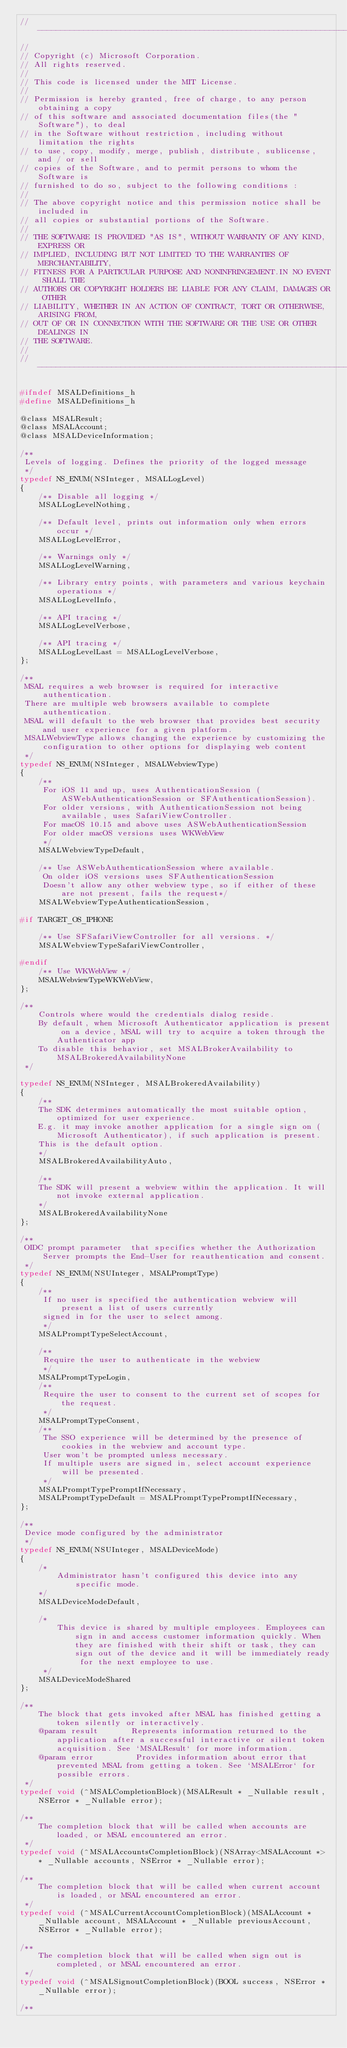Convert code to text. <code><loc_0><loc_0><loc_500><loc_500><_C_>//------------------------------------------------------------------------------
//
// Copyright (c) Microsoft Corporation.
// All rights reserved.
//
// This code is licensed under the MIT License.
//
// Permission is hereby granted, free of charge, to any person obtaining a copy
// of this software and associated documentation files(the "Software"), to deal
// in the Software without restriction, including without limitation the rights
// to use, copy, modify, merge, publish, distribute, sublicense, and / or sell
// copies of the Software, and to permit persons to whom the Software is
// furnished to do so, subject to the following conditions :
//
// The above copyright notice and this permission notice shall be included in
// all copies or substantial portions of the Software.
//
// THE SOFTWARE IS PROVIDED "AS IS", WITHOUT WARRANTY OF ANY KIND, EXPRESS OR
// IMPLIED, INCLUDING BUT NOT LIMITED TO THE WARRANTIES OF MERCHANTABILITY,
// FITNESS FOR A PARTICULAR PURPOSE AND NONINFRINGEMENT.IN NO EVENT SHALL THE
// AUTHORS OR COPYRIGHT HOLDERS BE LIABLE FOR ANY CLAIM, DAMAGES OR OTHER
// LIABILITY, WHETHER IN AN ACTION OF CONTRACT, TORT OR OTHERWISE, ARISING FROM,
// OUT OF OR IN CONNECTION WITH THE SOFTWARE OR THE USE OR OTHER DEALINGS IN
// THE SOFTWARE.
//
//------------------------------------------------------------------------------

#ifndef MSALDefinitions_h
#define MSALDefinitions_h

@class MSALResult;
@class MSALAccount;
@class MSALDeviceInformation;

/**
 Levels of logging. Defines the priority of the logged message
 */
typedef NS_ENUM(NSInteger, MSALLogLevel)
{
    /** Disable all logging */
    MSALLogLevelNothing,
    
    /** Default level, prints out information only when errors occur */
    MSALLogLevelError,
    
    /** Warnings only */
    MSALLogLevelWarning,
    
    /** Library entry points, with parameters and various keychain operations */
    MSALLogLevelInfo,
    
    /** API tracing */
    MSALLogLevelVerbose,
    
    /** API tracing */
    MSALLogLevelLast = MSALLogLevelVerbose,
};

/**
 MSAL requires a web browser is required for interactive authentication.
 There are multiple web browsers available to complete authentication.
 MSAL will default to the web browser that provides best security and user experience for a given platform.
 MSALWebviewType allows changing the experience by customizing the configuration to other options for displaying web content
 */
typedef NS_ENUM(NSInteger, MSALWebviewType)
{
    /**
     For iOS 11 and up, uses AuthenticationSession (ASWebAuthenticationSession or SFAuthenticationSession).
     For older versions, with AuthenticationSession not being available, uses SafariViewController.
     For macOS 10.15 and above uses ASWebAuthenticationSession
     For older macOS versions uses WKWebView
     */
    MSALWebviewTypeDefault,
    
    /** Use ASWebAuthenticationSession where available.
     On older iOS versions uses SFAuthenticationSession
     Doesn't allow any other webview type, so if either of these are not present, fails the request*/
    MSALWebviewTypeAuthenticationSession,
    
#if TARGET_OS_IPHONE
    
    /** Use SFSafariViewController for all versions. */
    MSALWebviewTypeSafariViewController,
    
#endif
    /** Use WKWebView */
    MSALWebviewTypeWKWebView,
};

/**
    Controls where would the credentials dialog reside.
    By default, when Microsoft Authenticator application is present on a device, MSAL will try to acquire a token through the Authenticator app
    To disable this behavior, set MSALBrokerAvailability to MSALBrokeredAvailabilityNone
 */

typedef NS_ENUM(NSInteger, MSALBrokeredAvailability)
{
    /**
    The SDK determines automatically the most suitable option, optimized for user experience.
    E.g. it may invoke another application for a single sign on (Microsoft Authenticator), if such application is present.
    This is the default option.
    */
    MSALBrokeredAvailabilityAuto,
    
    /**
    The SDK will present a webview within the application. It will not invoke external application.
    */
    MSALBrokeredAvailabilityNone
};

/**
 OIDC prompt parameter  that specifies whether the Authorization Server prompts the End-User for reauthentication and consent.
 */
typedef NS_ENUM(NSUInteger, MSALPromptType)
{
    /**
     If no user is specified the authentication webview will present a list of users currently
     signed in for the user to select among.
     */
    MSALPromptTypeSelectAccount,

    /**
     Require the user to authenticate in the webview
     */
    MSALPromptTypeLogin,
    /**
     Require the user to consent to the current set of scopes for the request.
     */
    MSALPromptTypeConsent,
    /**
     The SSO experience will be determined by the presence of cookies in the webview and account type.
     User won't be prompted unless necessary.
     If multiple users are signed in, select account experience will be presented.
     */
    MSALPromptTypePromptIfNecessary,
    MSALPromptTypeDefault = MSALPromptTypePromptIfNecessary,
};

/**
 Device mode configured by the administrator
 */
typedef NS_ENUM(NSUInteger, MSALDeviceMode)
{
    /*
        Administrator hasn't configured this device into any specific mode.
    */
    MSALDeviceModeDefault,
    
    /*
        This device is shared by multiple employees. Employees can sign in and access customer information quickly. When they are finished with their shift or task, they can sign out of the device and it will be immediately ready for the next employee to use.
     */
    MSALDeviceModeShared
};

/**
    The block that gets invoked after MSAL has finished getting a token silently or interactively.
    @param result       Represents information returned to the application after a successful interactive or silent token acquisition. See `MSALResult` for more information.
    @param error         Provides information about error that prevented MSAL from getting a token. See `MSALError` for possible errors.
 */
typedef void (^MSALCompletionBlock)(MSALResult * _Nullable result, NSError * _Nullable error);

/**
    The completion block that will be called when accounts are loaded, or MSAL encountered an error.
 */
typedef void (^MSALAccountsCompletionBlock)(NSArray<MSALAccount *> * _Nullable accounts, NSError * _Nullable error);

/**
    The completion block that will be called when current account is loaded, or MSAL encountered an error.
 */
typedef void (^MSALCurrentAccountCompletionBlock)(MSALAccount * _Nullable account, MSALAccount * _Nullable previousAccount, NSError * _Nullable error);

/**
    The completion block that will be called when sign out is completed, or MSAL encountered an error.
 */
typedef void (^MSALSignoutCompletionBlock)(BOOL success, NSError * _Nullable error);

/**</code> 